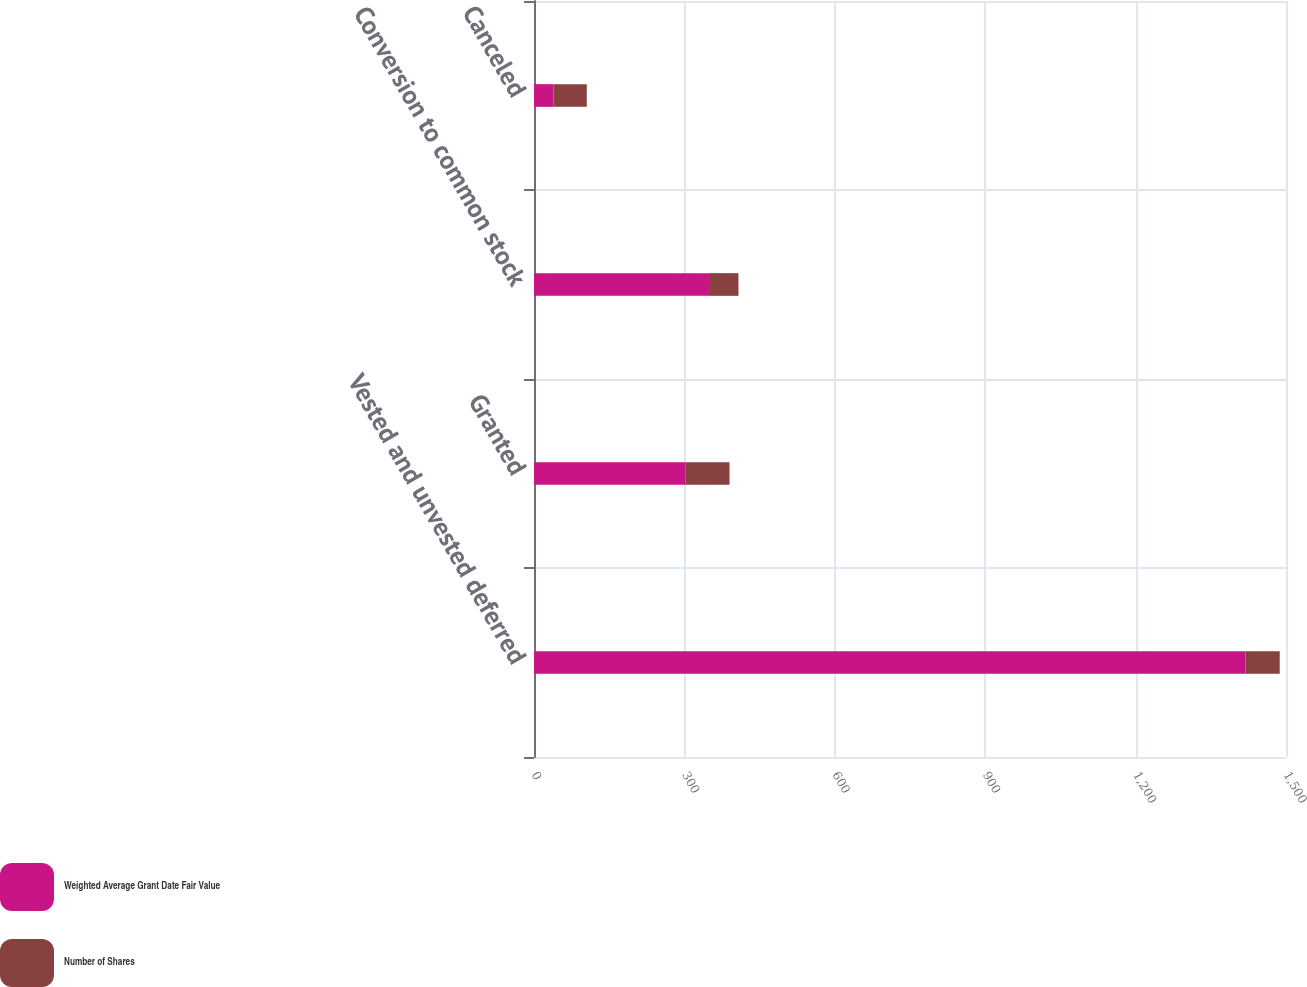<chart> <loc_0><loc_0><loc_500><loc_500><stacked_bar_chart><ecel><fcel>Vested and unvested deferred<fcel>Granted<fcel>Conversion to common stock<fcel>Canceled<nl><fcel>Weighted Average Grant Date Fair Value<fcel>1419<fcel>302<fcel>351<fcel>39<nl><fcel>Number of Shares<fcel>68.5<fcel>88.01<fcel>56.83<fcel>66.25<nl></chart> 